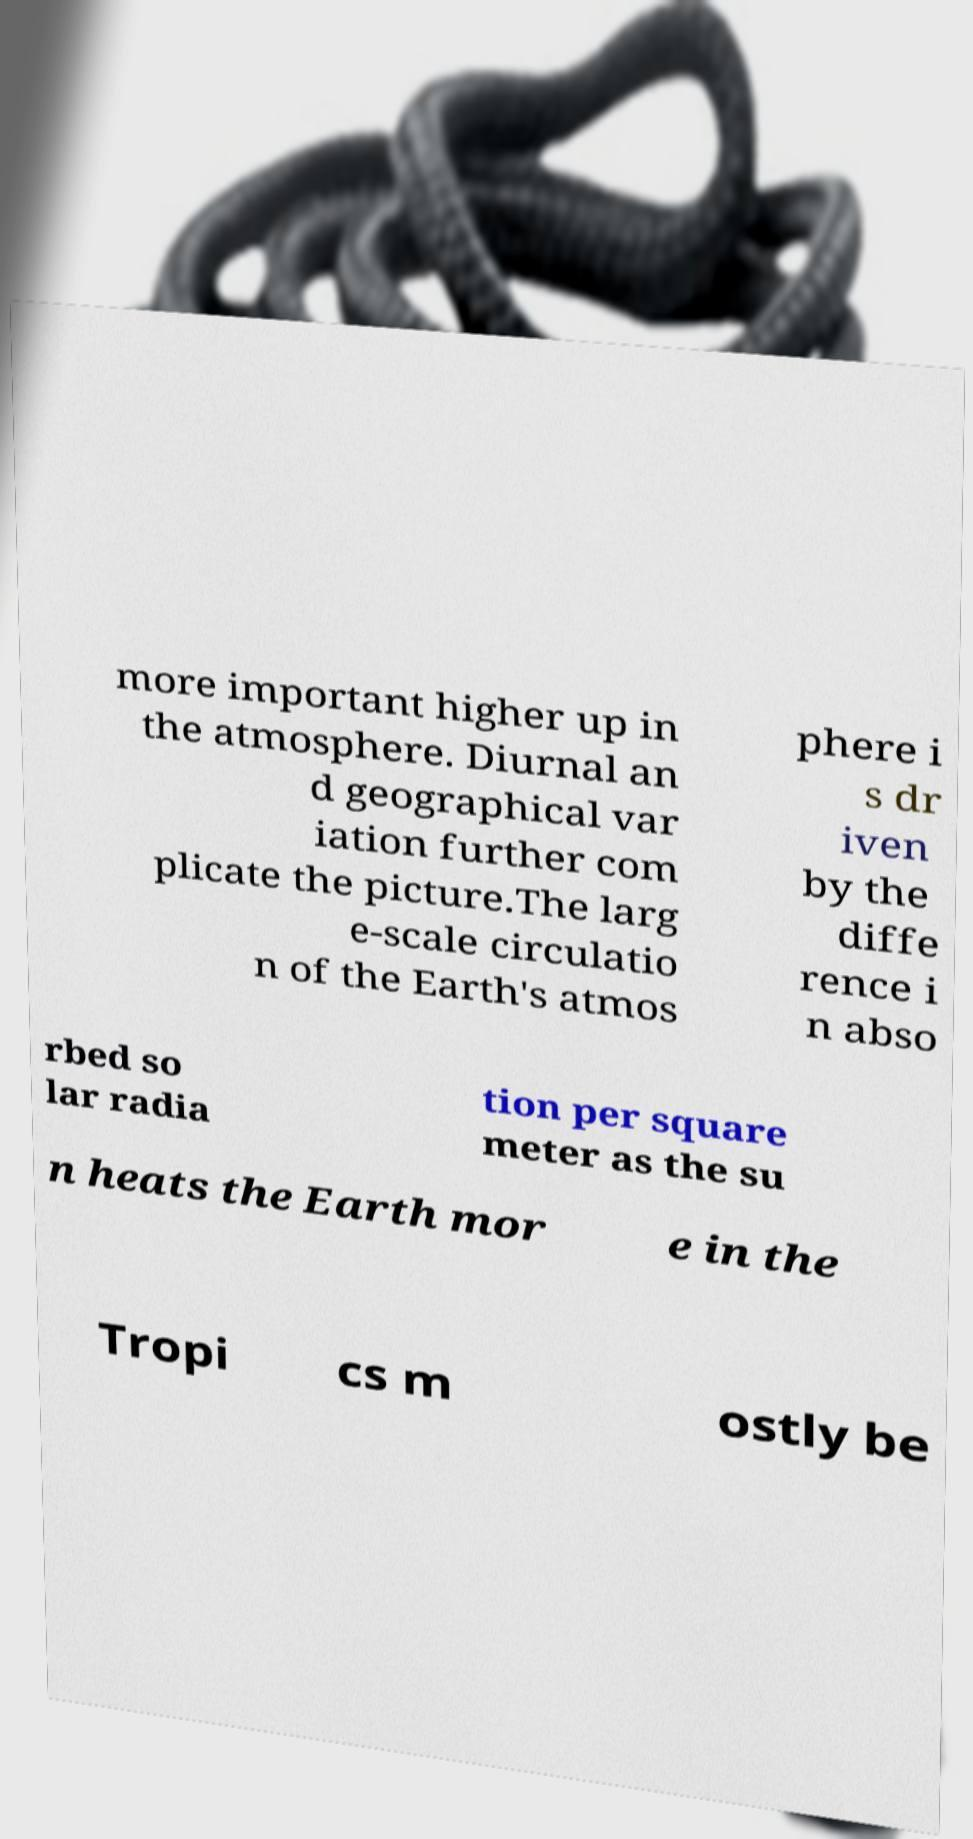Can you read and provide the text displayed in the image?This photo seems to have some interesting text. Can you extract and type it out for me? more important higher up in the atmosphere. Diurnal an d geographical var iation further com plicate the picture.The larg e-scale circulatio n of the Earth's atmos phere i s dr iven by the diffe rence i n abso rbed so lar radia tion per square meter as the su n heats the Earth mor e in the Tropi cs m ostly be 